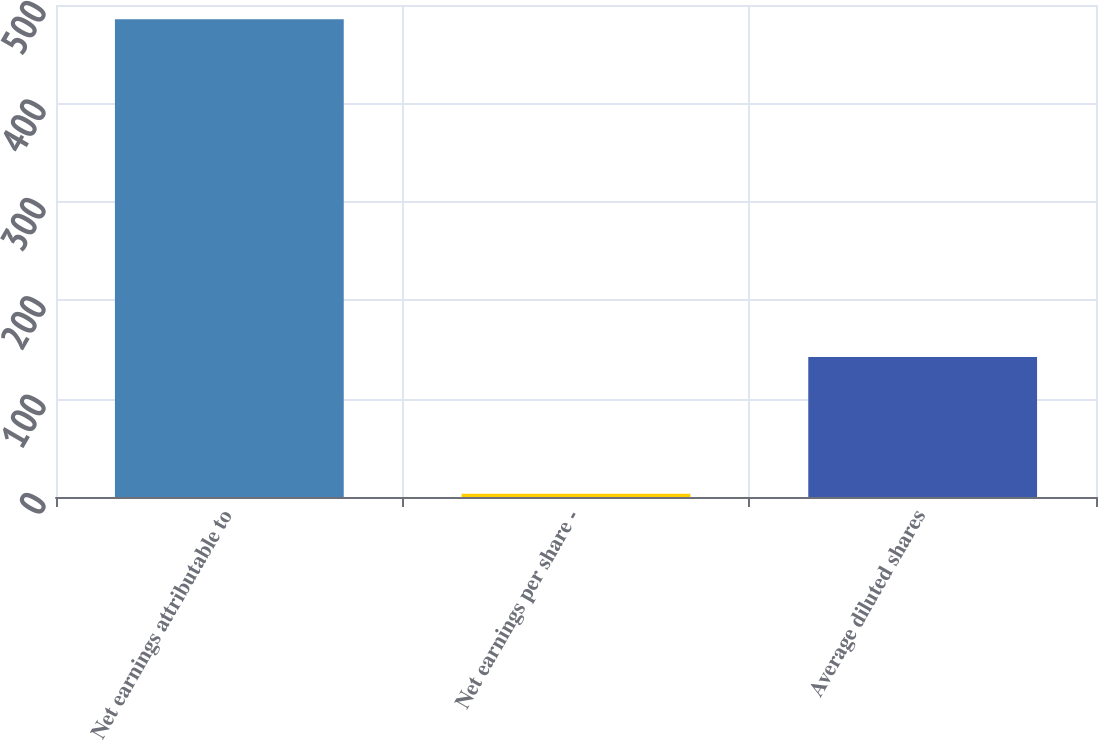Convert chart to OTSL. <chart><loc_0><loc_0><loc_500><loc_500><bar_chart><fcel>Net earnings attributable to<fcel>Net earnings per share -<fcel>Average diluted shares<nl><fcel>485.5<fcel>3.41<fcel>142.4<nl></chart> 